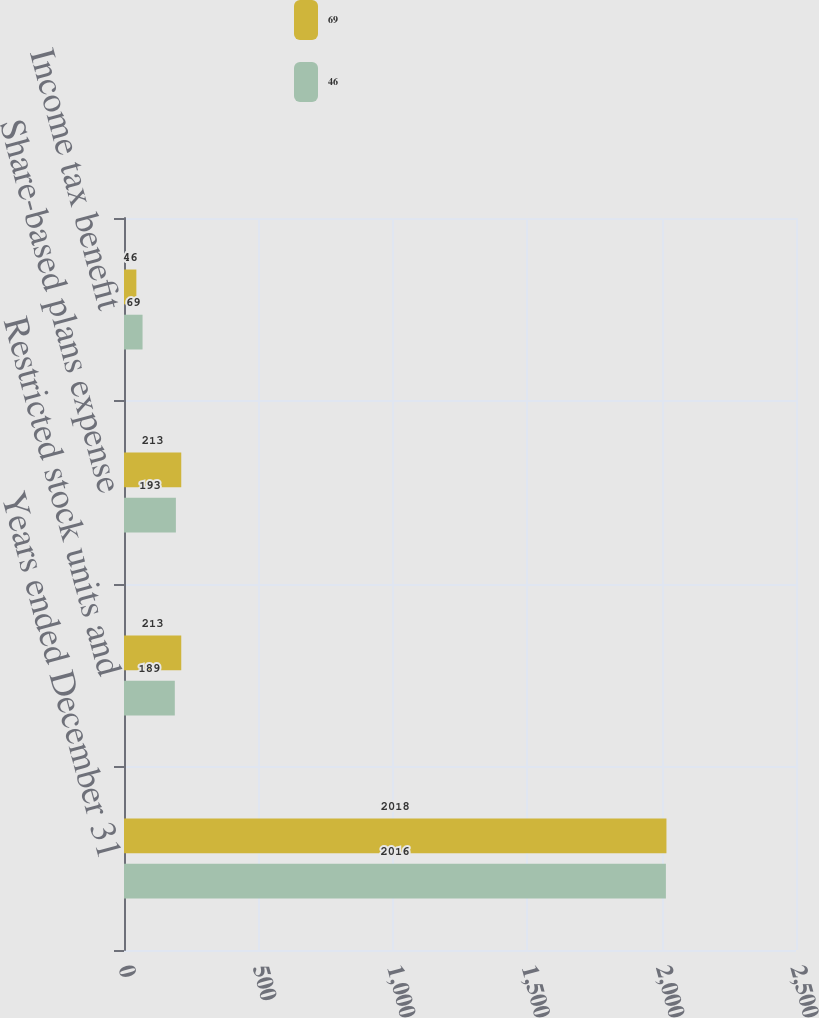Convert chart. <chart><loc_0><loc_0><loc_500><loc_500><stacked_bar_chart><ecel><fcel>Years ended December 31<fcel>Restricted stock units and<fcel>Share-based plans expense<fcel>Income tax benefit<nl><fcel>69<fcel>2018<fcel>213<fcel>213<fcel>46<nl><fcel>46<fcel>2016<fcel>189<fcel>193<fcel>69<nl></chart> 